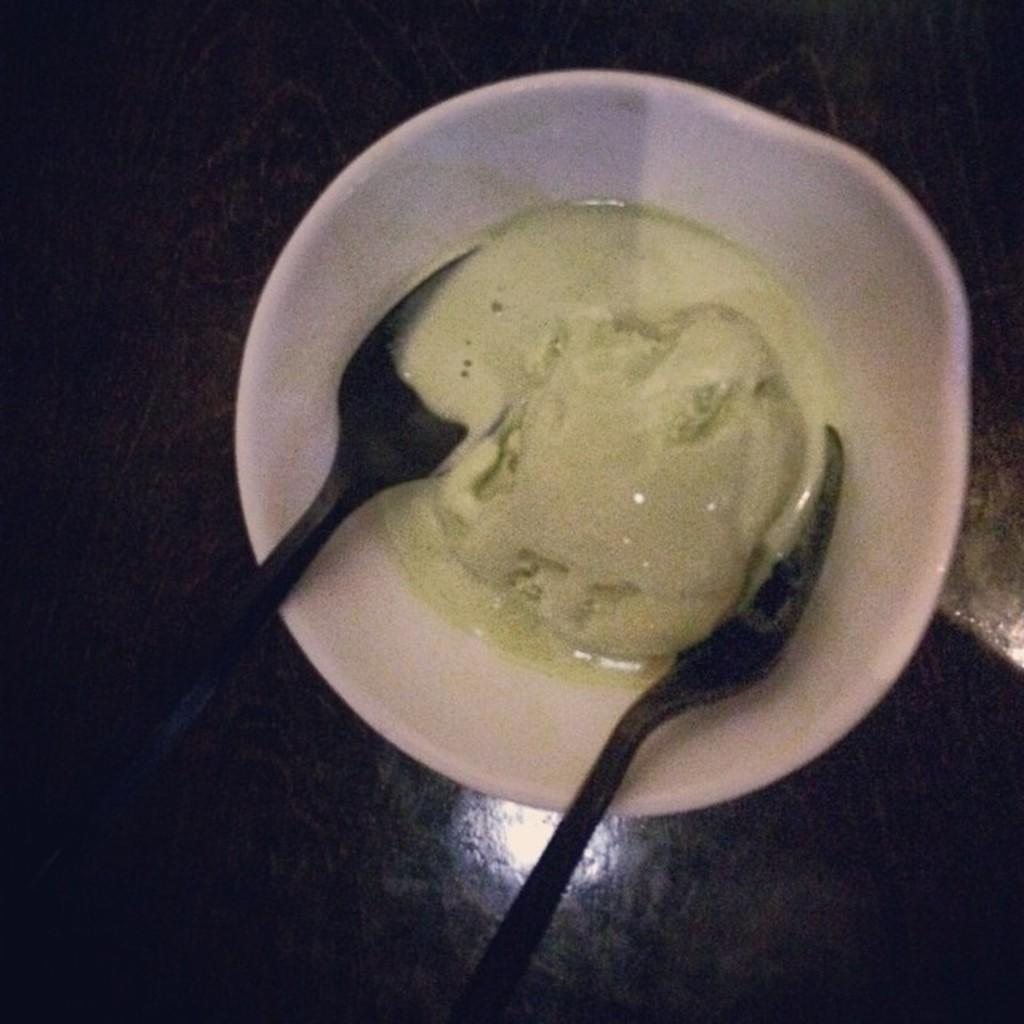What type of food item is in the image? The specific type of food item is not mentioned, but it is a food item in the image. How is the food item contained in the image? The food item is in a white bowl. What utensils are present in the image? There are two black spoons in the image. What is the surface that the bowl and spoons are placed on? The bowl and spoons are placed on a wooden surface. Are there any giants arguing about a disease in the image? No, there are no giants, arguments, or diseases present in the image. 